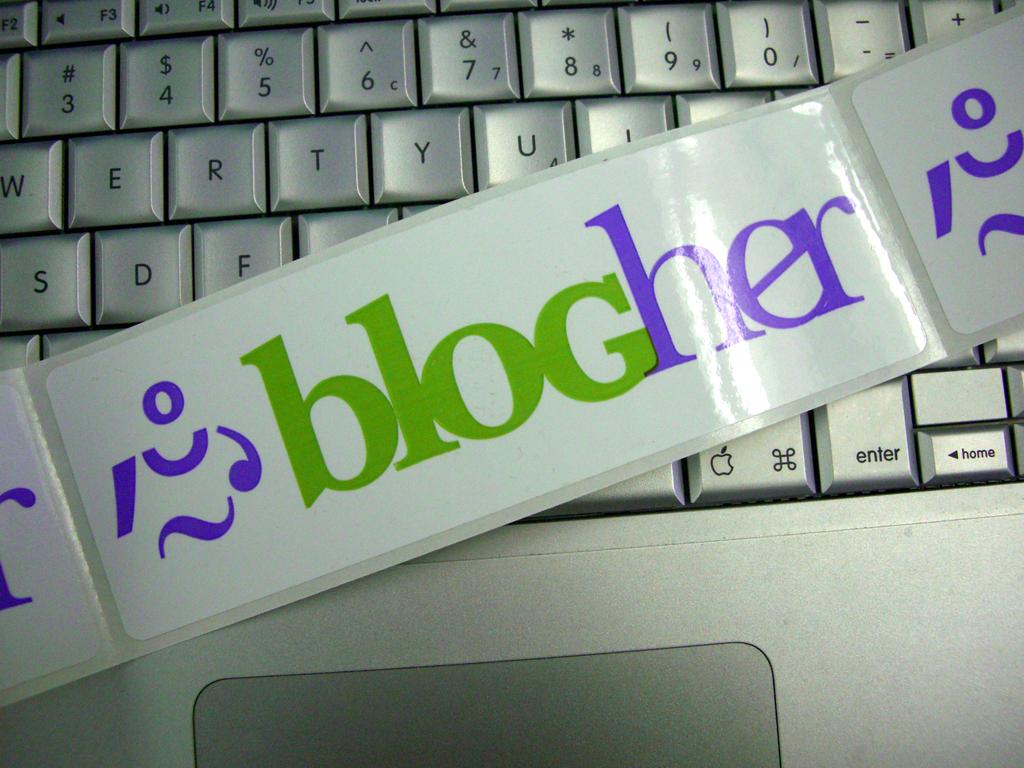What is the name of the organization?
Ensure brevity in your answer.  Blogher. What does the sticker say?
Ensure brevity in your answer.  Blogher. 